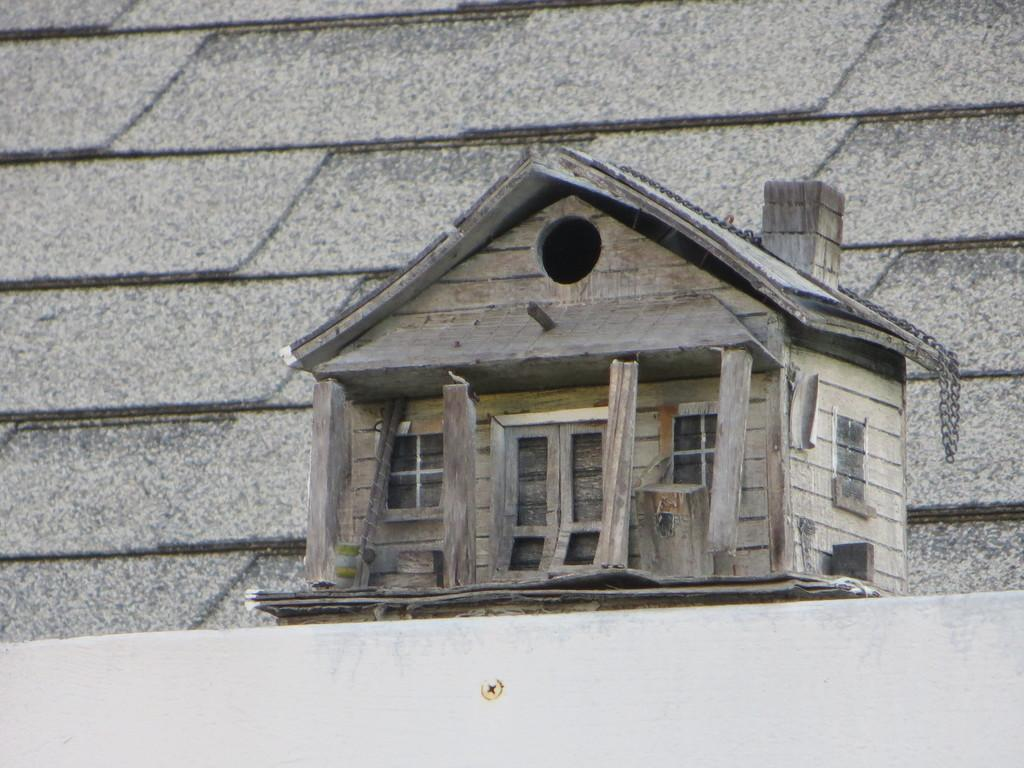What type of house is visible in the image? There is a wooden house in the image. What else can be seen in the image besides the house? There is a wall in the image. Can you tell if the image was taken during the day or night? The image was likely taken during the day, as there is no indication of darkness or artificial lighting. What role does the minister play in the image? There is no minister present in the image. How is the brother related to the wooden house in the image? There is no brother mentioned or depicted in the image. 